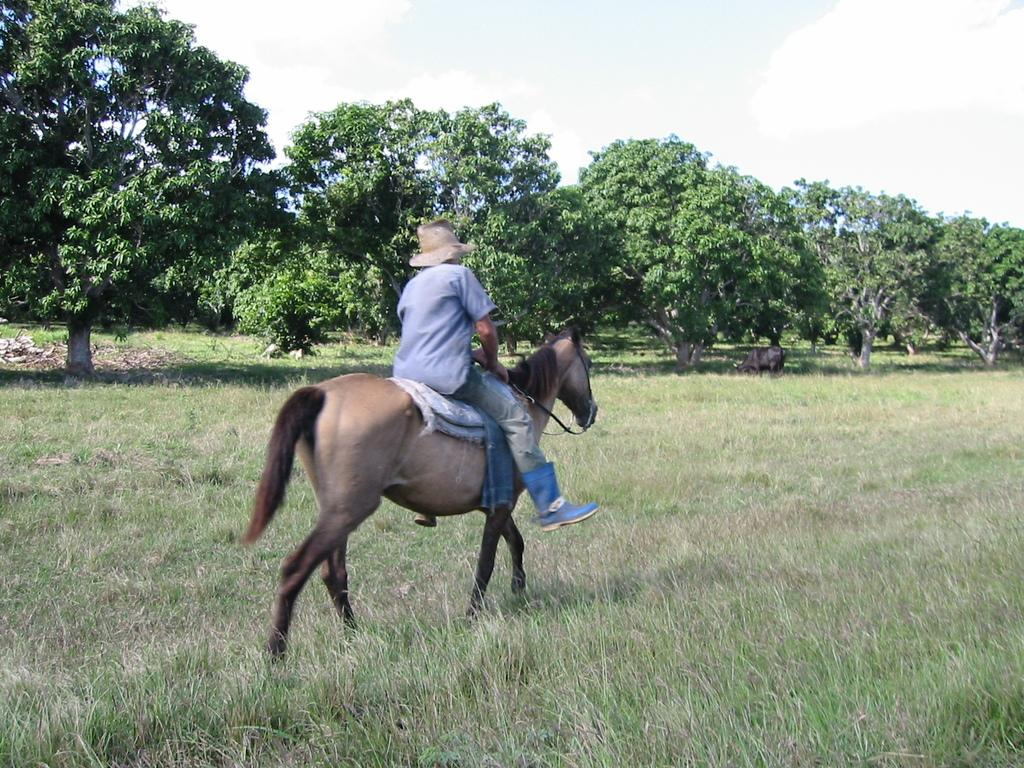What is the person in the image doing? The person is riding a horse in the image. What type of clothing is the person wearing on their head? The person is wearing a hat in the image. What color is the shirt the person is wearing? The person is wearing a blue shirt in the image. What type of footwear is the person wearing? The person is wearing blue boots in the image. What can be seen in the background of the image? There are trees visible in the background of the image. What type of baseball equipment can be seen in the image? There is no baseball equipment present in the image; it features a person riding a horse. What type of playground equipment can be seen in the image? There is no playground equipment present in the image; it features a person riding a horse. 